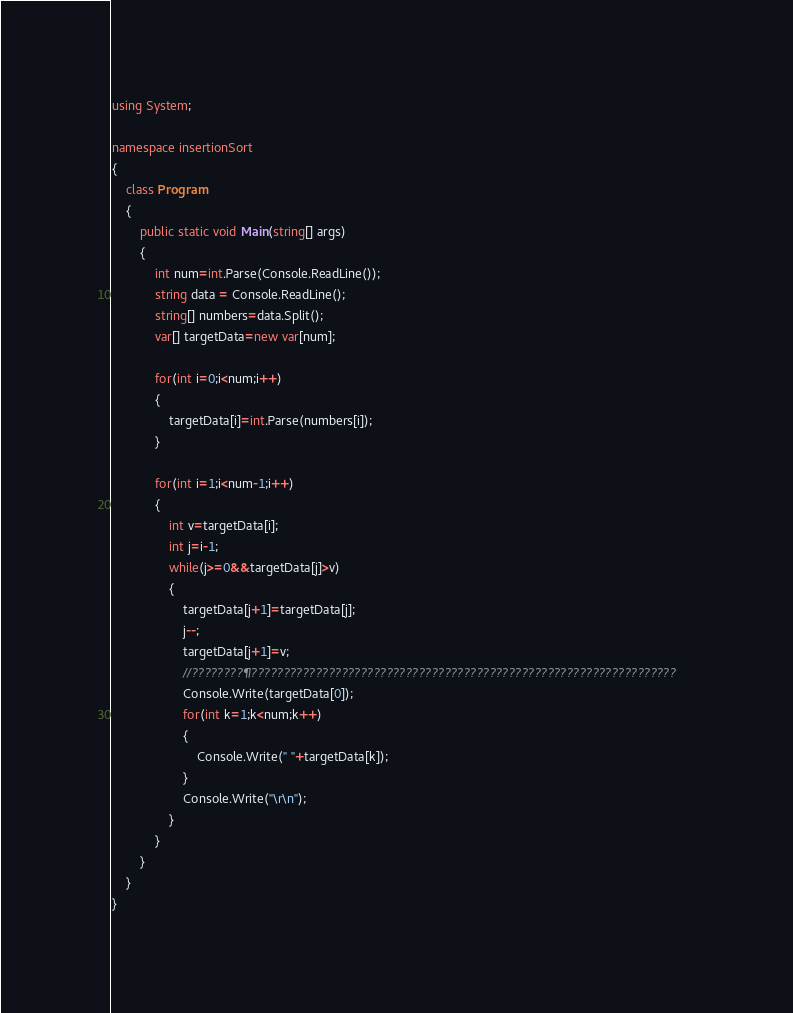<code> <loc_0><loc_0><loc_500><loc_500><_C#_>
using System;

namespace insertionSort
{
	class Program
	{
		public static void Main(string[] args)
		{
			int num=int.Parse(Console.ReadLine());
			string data = Console.ReadLine();
			string[] numbers=data.Split();
			var[] targetData=new var[num];
				
			for(int i=0;i<num;i++)
			{
				targetData[i]=int.Parse(numbers[i]);
			}
			
			for(int i=1;i<num-1;i++)
			{
				int v=targetData[i];
				int j=i-1;
				while(j>=0&&targetData[j]>v)
				{
					targetData[j+1]=targetData[j];
					j--;
					targetData[j+1]=v;
					//????????¶??????????????????????????????????????????????????????????????????
					Console.Write(targetData[0]);
					for(int k=1;k<num;k++)
					{
						Console.Write(" "+targetData[k]);
					}
					Console.Write("\r\n");
				}
			}
		}
	}
}</code> 